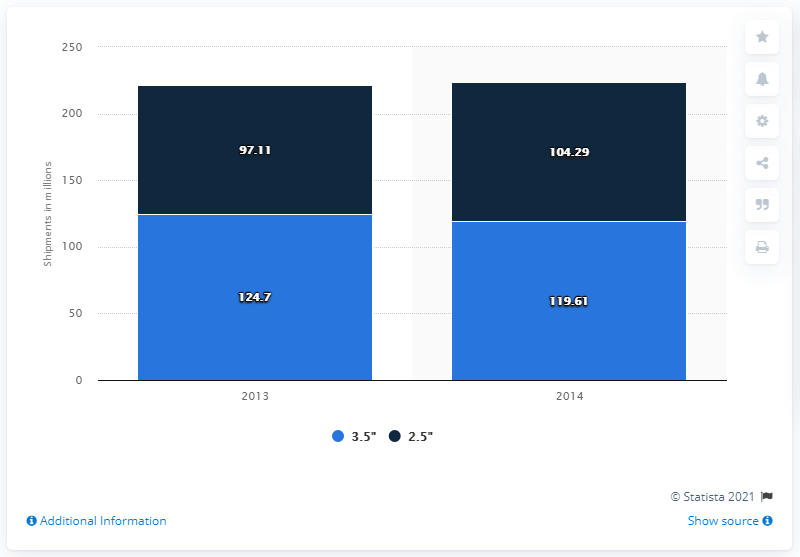Highlight a few significant elements in this photo. Seagate shipped 119,610 3.5-inch hard disk drives in 2014. In 2013, a total of 124.7 million 3.5-inch hard disk drives were shipped. During the years 2013 and 2014, a total of 244.31 million 3.5-inch hard disk drives were shipped. 